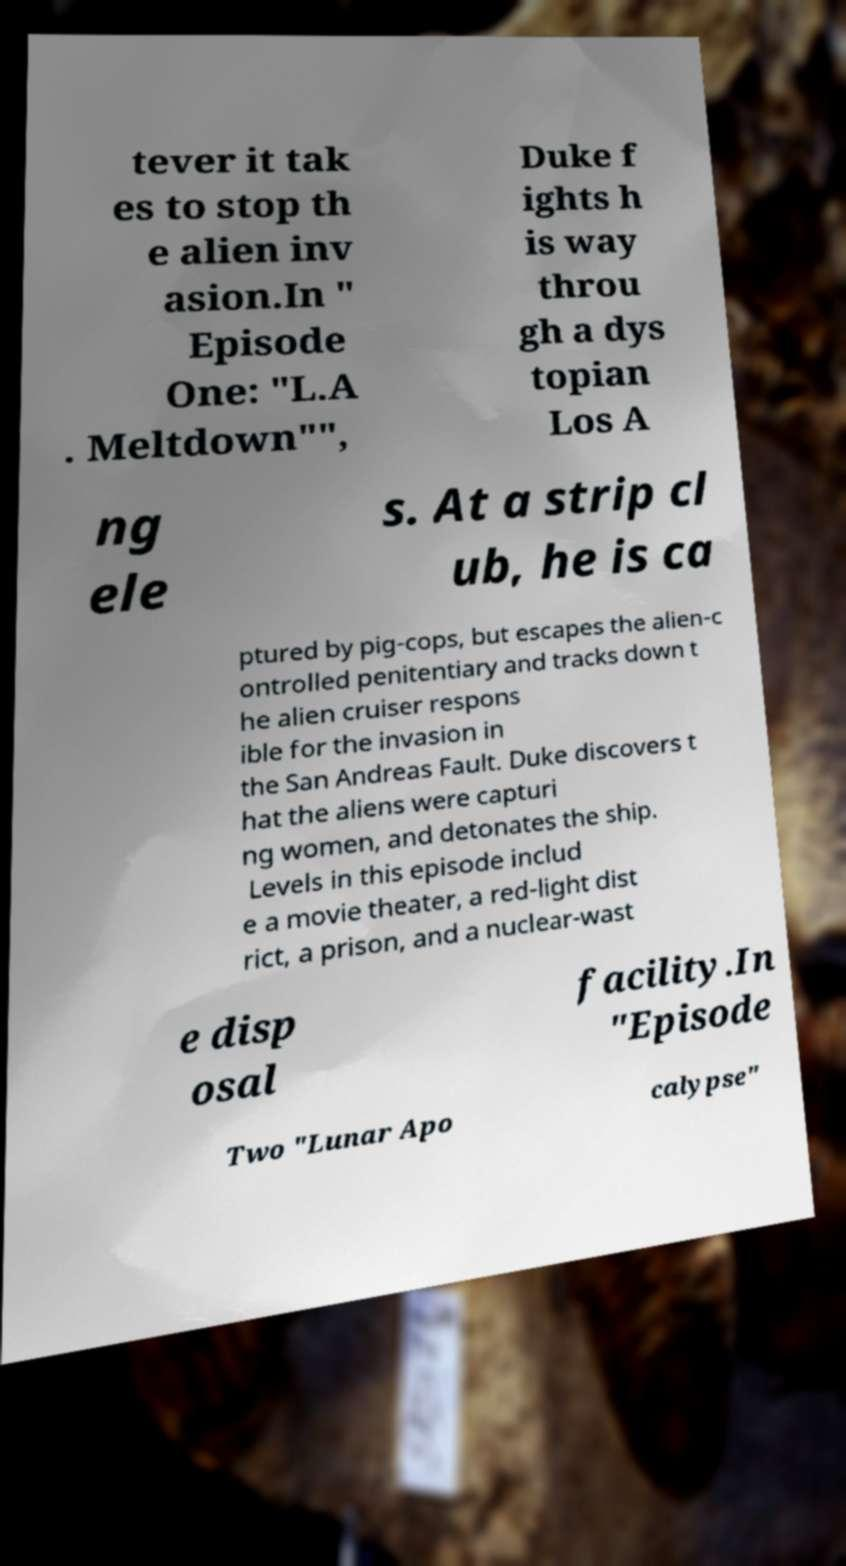Could you assist in decoding the text presented in this image and type it out clearly? tever it tak es to stop th e alien inv asion.In " Episode One: "L.A . Meltdown"", Duke f ights h is way throu gh a dys topian Los A ng ele s. At a strip cl ub, he is ca ptured by pig-cops, but escapes the alien-c ontrolled penitentiary and tracks down t he alien cruiser respons ible for the invasion in the San Andreas Fault. Duke discovers t hat the aliens were capturi ng women, and detonates the ship. Levels in this episode includ e a movie theater, a red-light dist rict, a prison, and a nuclear-wast e disp osal facility.In "Episode Two "Lunar Apo calypse" 